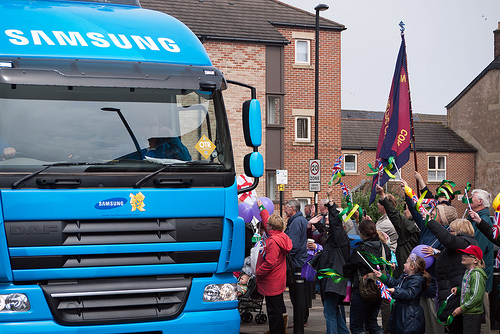<image>
Is there a bus above the people? No. The bus is not positioned above the people. The vertical arrangement shows a different relationship. 